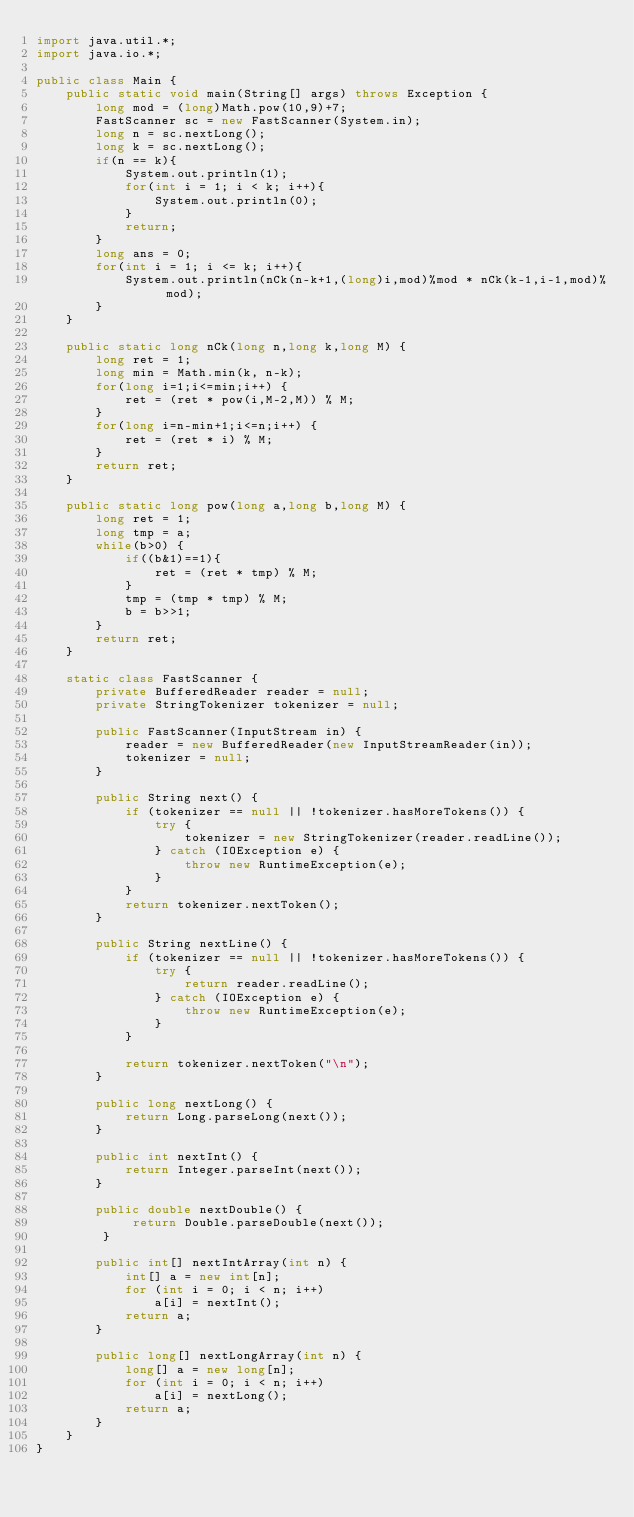Convert code to text. <code><loc_0><loc_0><loc_500><loc_500><_Java_>import java.util.*;
import java.io.*;
 
public class Main {
    public static void main(String[] args) throws Exception {
        long mod = (long)Math.pow(10,9)+7;
        FastScanner sc = new FastScanner(System.in);
        long n = sc.nextLong();
        long k = sc.nextLong();
        if(n == k){
            System.out.println(1);
            for(int i = 1; i < k; i++){
                System.out.println(0);
            }
            return;
        }
        long ans = 0;
        for(int i = 1; i <= k; i++){
            System.out.println(nCk(n-k+1,(long)i,mod)%mod * nCk(k-1,i-1,mod)% mod);
        }
    }
    
    public static long nCk(long n,long k,long M) {
        long ret = 1;
        long min = Math.min(k, n-k);
        for(long i=1;i<=min;i++) {
            ret = (ret * pow(i,M-2,M)) % M;
        }
        for(long i=n-min+1;i<=n;i++) {
            ret = (ret * i) % M;
        }
        return ret;
    }

    public static long pow(long a,long b,long M) {
        long ret = 1;
        long tmp = a;
        while(b>0) {
            if((b&1)==1){
                ret = (ret * tmp) % M;
            }
            tmp = (tmp * tmp) % M;
            b = b>>1;
        }
        return ret;
    }
    
    static class FastScanner {
        private BufferedReader reader = null;
        private StringTokenizer tokenizer = null;

        public FastScanner(InputStream in) {
            reader = new BufferedReader(new InputStreamReader(in));
            tokenizer = null;
        }

        public String next() {
            if (tokenizer == null || !tokenizer.hasMoreTokens()) {
                try {
                    tokenizer = new StringTokenizer(reader.readLine());
                } catch (IOException e) {
                    throw new RuntimeException(e);
                }
            }
            return tokenizer.nextToken();
        }

        public String nextLine() {
            if (tokenizer == null || !tokenizer.hasMoreTokens()) {
                try {
                    return reader.readLine();
                } catch (IOException e) {
                    throw new RuntimeException(e);
                }
            }

            return tokenizer.nextToken("\n");
        }

        public long nextLong() {
            return Long.parseLong(next());
        }

        public int nextInt() {
            return Integer.parseInt(next());
        }

        public double nextDouble() {
             return Double.parseDouble(next());
         }

        public int[] nextIntArray(int n) {
            int[] a = new int[n];
            for (int i = 0; i < n; i++)
                a[i] = nextInt();
            return a;
        }

        public long[] nextLongArray(int n) {
            long[] a = new long[n];
            for (int i = 0; i < n; i++)
                a[i] = nextLong();
            return a;
        } 
    }
}
</code> 